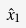<formula> <loc_0><loc_0><loc_500><loc_500>\hat { x } _ { 1 }</formula> 